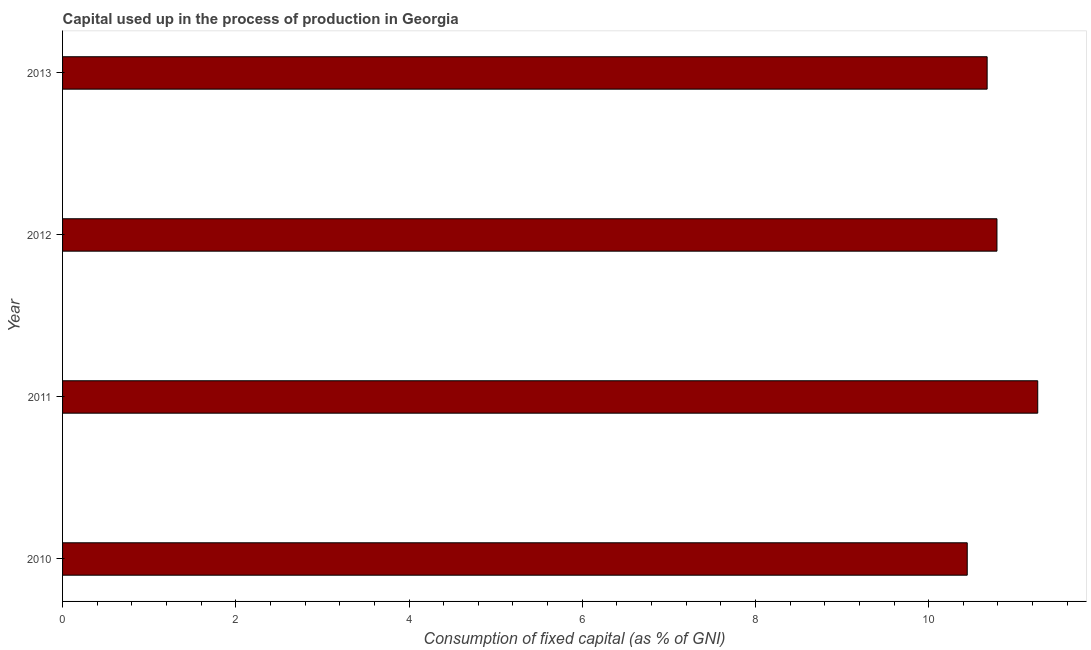Does the graph contain any zero values?
Provide a short and direct response. No. Does the graph contain grids?
Your response must be concise. No. What is the title of the graph?
Your answer should be very brief. Capital used up in the process of production in Georgia. What is the label or title of the X-axis?
Keep it short and to the point. Consumption of fixed capital (as % of GNI). What is the label or title of the Y-axis?
Make the answer very short. Year. What is the consumption of fixed capital in 2013?
Provide a succinct answer. 10.68. Across all years, what is the maximum consumption of fixed capital?
Your answer should be compact. 11.26. Across all years, what is the minimum consumption of fixed capital?
Make the answer very short. 10.45. What is the sum of the consumption of fixed capital?
Your answer should be very brief. 43.17. What is the difference between the consumption of fixed capital in 2011 and 2012?
Keep it short and to the point. 0.47. What is the average consumption of fixed capital per year?
Your answer should be compact. 10.79. What is the median consumption of fixed capital?
Provide a succinct answer. 10.73. In how many years, is the consumption of fixed capital greater than 4.4 %?
Make the answer very short. 4. What is the ratio of the consumption of fixed capital in 2010 to that in 2012?
Provide a succinct answer. 0.97. Is the difference between the consumption of fixed capital in 2010 and 2012 greater than the difference between any two years?
Offer a very short reply. No. What is the difference between the highest and the second highest consumption of fixed capital?
Offer a very short reply. 0.47. What is the difference between the highest and the lowest consumption of fixed capital?
Make the answer very short. 0.81. In how many years, is the consumption of fixed capital greater than the average consumption of fixed capital taken over all years?
Make the answer very short. 1. Are all the bars in the graph horizontal?
Provide a succinct answer. Yes. How many years are there in the graph?
Make the answer very short. 4. What is the difference between two consecutive major ticks on the X-axis?
Give a very brief answer. 2. Are the values on the major ticks of X-axis written in scientific E-notation?
Make the answer very short. No. What is the Consumption of fixed capital (as % of GNI) in 2010?
Provide a succinct answer. 10.45. What is the Consumption of fixed capital (as % of GNI) in 2011?
Give a very brief answer. 11.26. What is the Consumption of fixed capital (as % of GNI) in 2012?
Offer a terse response. 10.79. What is the Consumption of fixed capital (as % of GNI) in 2013?
Make the answer very short. 10.68. What is the difference between the Consumption of fixed capital (as % of GNI) in 2010 and 2011?
Keep it short and to the point. -0.81. What is the difference between the Consumption of fixed capital (as % of GNI) in 2010 and 2012?
Your response must be concise. -0.34. What is the difference between the Consumption of fixed capital (as % of GNI) in 2010 and 2013?
Keep it short and to the point. -0.23. What is the difference between the Consumption of fixed capital (as % of GNI) in 2011 and 2012?
Offer a terse response. 0.47. What is the difference between the Consumption of fixed capital (as % of GNI) in 2011 and 2013?
Offer a very short reply. 0.58. What is the difference between the Consumption of fixed capital (as % of GNI) in 2012 and 2013?
Provide a short and direct response. 0.11. What is the ratio of the Consumption of fixed capital (as % of GNI) in 2010 to that in 2011?
Your answer should be compact. 0.93. What is the ratio of the Consumption of fixed capital (as % of GNI) in 2011 to that in 2012?
Provide a short and direct response. 1.04. What is the ratio of the Consumption of fixed capital (as % of GNI) in 2011 to that in 2013?
Provide a short and direct response. 1.05. 